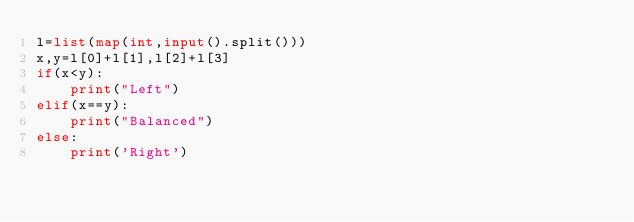Convert code to text. <code><loc_0><loc_0><loc_500><loc_500><_Python_>l=list(map(int,input().split()))
x,y=l[0]+l[1],l[2]+l[3]
if(x<y):
    print("Left")
elif(x==y):
    print("Balanced")
else:
    print('Right')</code> 